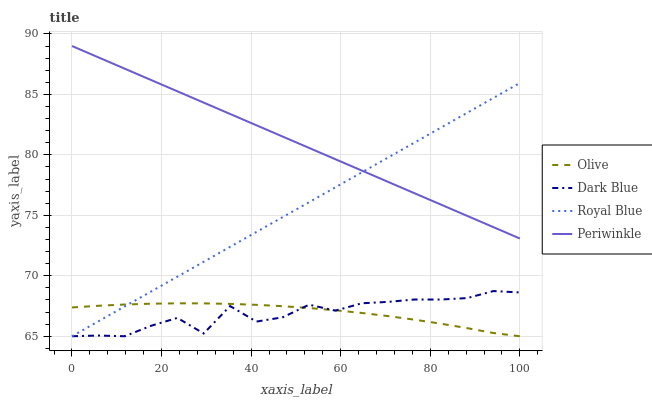Does Dark Blue have the minimum area under the curve?
Answer yes or no. Yes. Does Periwinkle have the maximum area under the curve?
Answer yes or no. Yes. Does Periwinkle have the minimum area under the curve?
Answer yes or no. No. Does Dark Blue have the maximum area under the curve?
Answer yes or no. No. Is Royal Blue the smoothest?
Answer yes or no. Yes. Is Dark Blue the roughest?
Answer yes or no. Yes. Is Periwinkle the smoothest?
Answer yes or no. No. Is Periwinkle the roughest?
Answer yes or no. No. Does Olive have the lowest value?
Answer yes or no. Yes. Does Periwinkle have the lowest value?
Answer yes or no. No. Does Periwinkle have the highest value?
Answer yes or no. Yes. Does Dark Blue have the highest value?
Answer yes or no. No. Is Dark Blue less than Periwinkle?
Answer yes or no. Yes. Is Periwinkle greater than Dark Blue?
Answer yes or no. Yes. Does Royal Blue intersect Periwinkle?
Answer yes or no. Yes. Is Royal Blue less than Periwinkle?
Answer yes or no. No. Is Royal Blue greater than Periwinkle?
Answer yes or no. No. Does Dark Blue intersect Periwinkle?
Answer yes or no. No. 